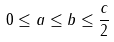Convert formula to latex. <formula><loc_0><loc_0><loc_500><loc_500>0 \leq a \leq b \leq \frac { c } { 2 }</formula> 